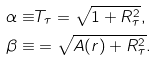<formula> <loc_0><loc_0><loc_500><loc_500>\alpha \equiv & T _ { \tau } = \sqrt { 1 + R _ { \tau } ^ { 2 } } , \\ \beta \equiv & = \sqrt { A ( r ) + R _ { \tau } ^ { 2 } } .</formula> 